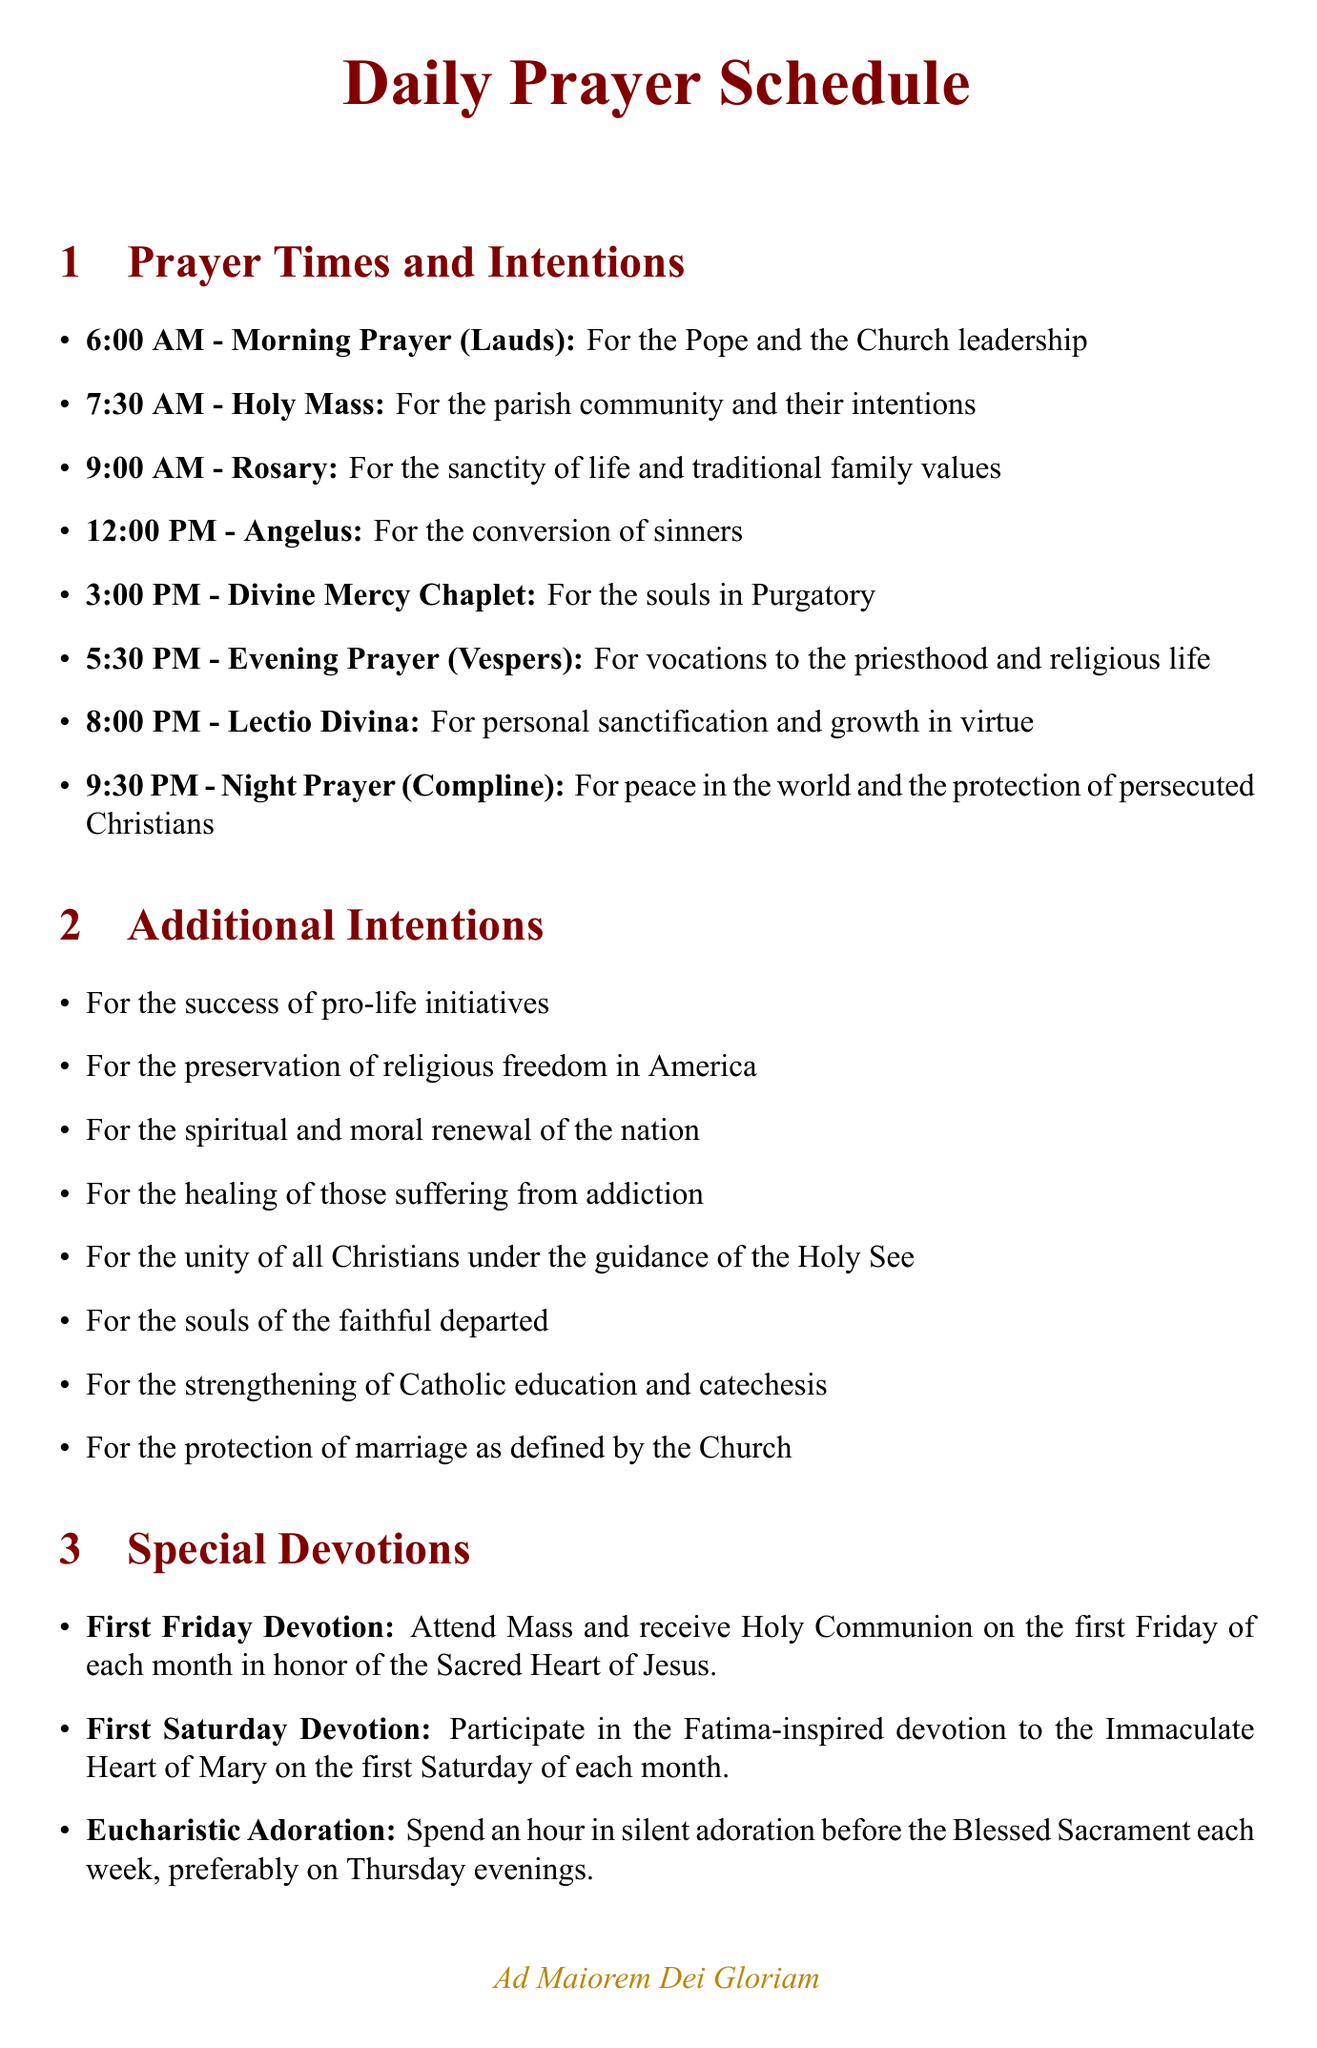what time is the Morning Prayer scheduled? The Morning Prayer (Lauds) is scheduled for 6:00 AM as listed in the daily prayer schedule.
Answer: 6:00 AM what is the intention for the Rosary? The intention for the Rosary is specified in the schedule as "For the sanctity of life and traditional family values."
Answer: For the sanctity of life and traditional family values how many prayer activities are scheduled before noon? The document lists the prayer activities scheduled before noon, which are Morning Prayer, Holy Mass, and the Rosary, totaling three.
Answer: 3 what is the name of the devotion on the first Saturday of each month? The devotion is identified as the "First Saturday Devotion," as stated in the special devotions section.
Answer: First Saturday Devotion what is prayed during the Divine Mercy Chaplet? The document states that the Divine Mercy Chaplet focuses on God's mercy and the redemption of souls.
Answer: God's mercy and the redemption of souls what time is the Night Prayer scheduled? The Night Prayer (Compline) is scheduled for 9:30 PM according to the daily prayer schedule.
Answer: 9:30 PM which prayer focuses on vocations? The Evening Prayer (Vespers) is specifically focused on vocations to the priesthood and religious life.
Answer: Evening Prayer (Vespers) how often should Eucharistic Adoration be observed? The document indicates that Eucharistic Adoration should be spent each week, preferably on Thursday evenings.
Answer: Each week 